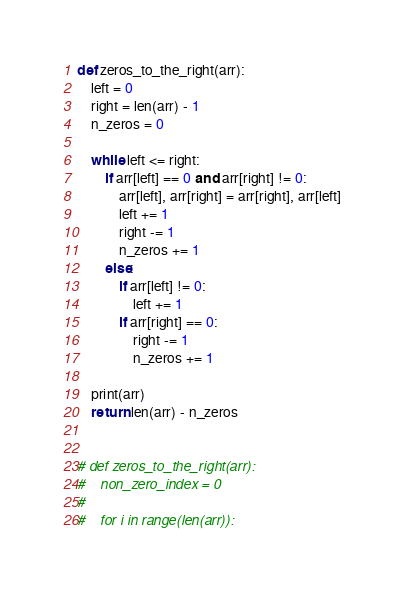Convert code to text. <code><loc_0><loc_0><loc_500><loc_500><_Python_>def zeros_to_the_right(arr):
    left = 0
    right = len(arr) - 1
    n_zeros = 0

    while left <= right:
        if arr[left] == 0 and arr[right] != 0:
            arr[left], arr[right] = arr[right], arr[left]
            left += 1
            right -= 1
            n_zeros += 1
        else:
            if arr[left] != 0:
                left += 1
            if arr[right] == 0:
                right -= 1
                n_zeros += 1

    print(arr)
    return len(arr) - n_zeros


# def zeros_to_the_right(arr):
#    non_zero_index = 0
#
#    for i in range(len(arr)):</code> 